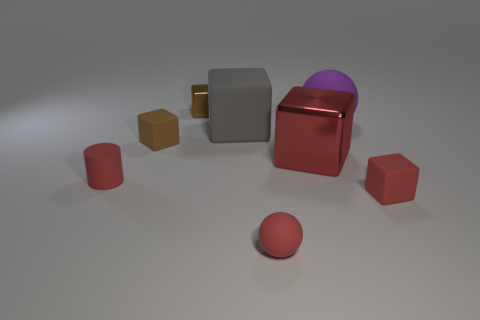Subtract all green spheres. Subtract all green cubes. How many spheres are left? 2 Add 2 large cubes. How many objects exist? 10 Subtract all spheres. How many objects are left? 6 Subtract all small yellow balls. Subtract all big gray matte things. How many objects are left? 7 Add 4 purple balls. How many purple balls are left? 5 Add 6 big purple objects. How many big purple objects exist? 7 Subtract 0 blue cylinders. How many objects are left? 8 